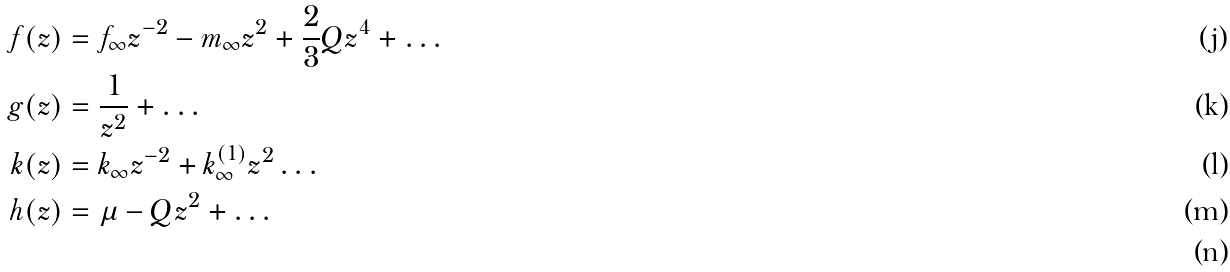<formula> <loc_0><loc_0><loc_500><loc_500>f ( z ) & = f _ { \infty } z ^ { - 2 } - m _ { \infty } z ^ { 2 } + \frac { 2 } { 3 } Q z ^ { 4 } + \dots \\ g ( z ) & = \frac { 1 } { z ^ { 2 } } + \dots \\ k ( z ) & = k _ { \infty } z ^ { - 2 } + k ^ { ( 1 ) } _ { \infty } z ^ { 2 } \dots \\ h ( z ) & = \mu - Q z ^ { 2 } + \dots \\</formula> 